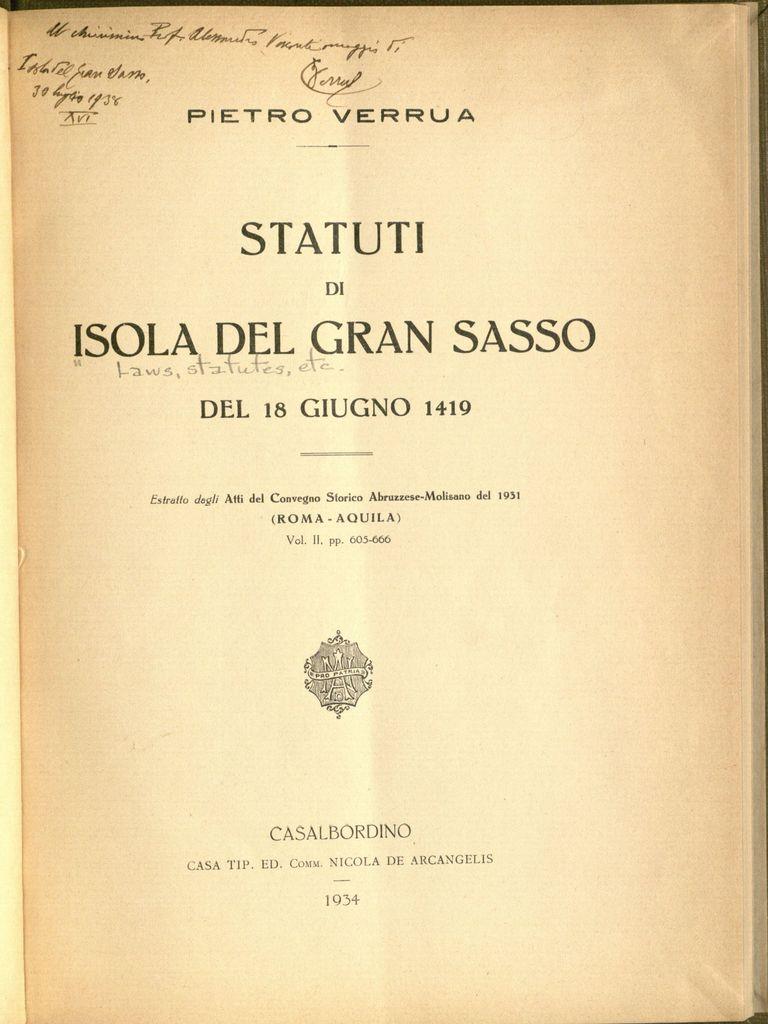Who authored this book?
Make the answer very short. Pietro verrua. 